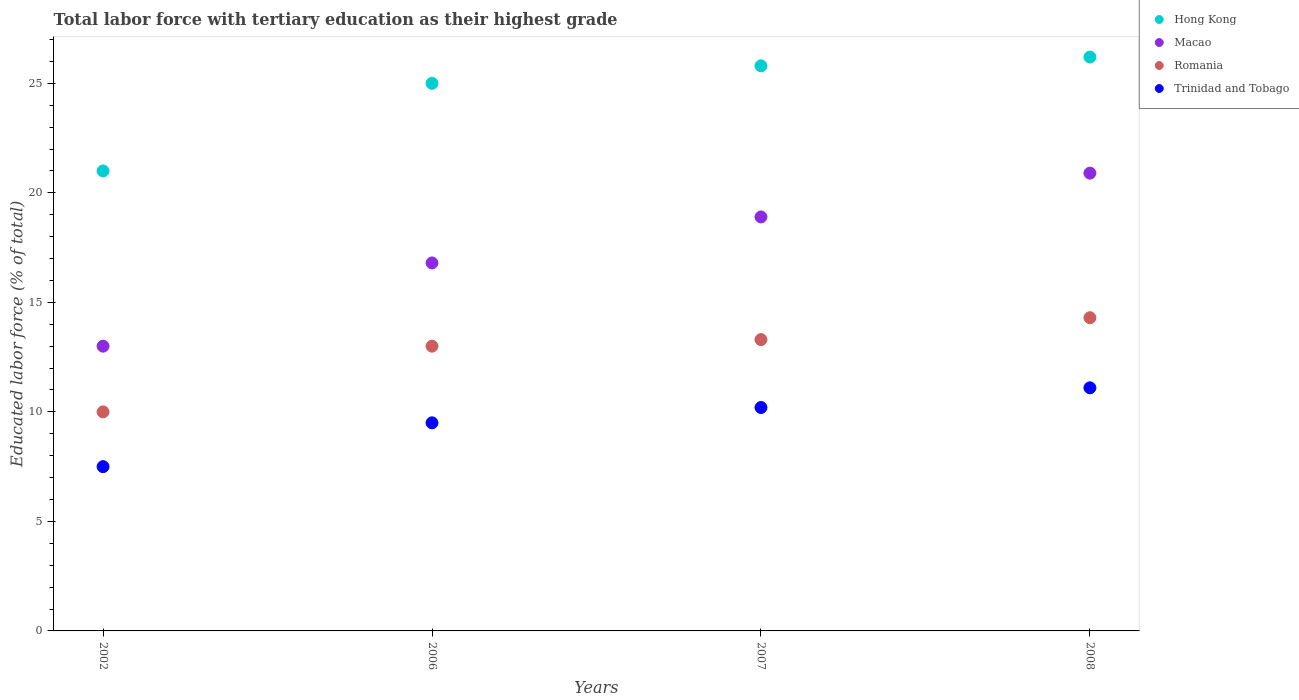How many different coloured dotlines are there?
Provide a short and direct response. 4. Is the number of dotlines equal to the number of legend labels?
Keep it short and to the point. Yes. What is the percentage of male labor force with tertiary education in Trinidad and Tobago in 2007?
Offer a terse response. 10.2. Across all years, what is the maximum percentage of male labor force with tertiary education in Trinidad and Tobago?
Your answer should be compact. 11.1. In which year was the percentage of male labor force with tertiary education in Romania maximum?
Give a very brief answer. 2008. What is the total percentage of male labor force with tertiary education in Macao in the graph?
Provide a short and direct response. 69.6. What is the difference between the percentage of male labor force with tertiary education in Macao in 2006 and that in 2007?
Ensure brevity in your answer.  -2.1. What is the difference between the percentage of male labor force with tertiary education in Hong Kong in 2006 and the percentage of male labor force with tertiary education in Trinidad and Tobago in 2008?
Your answer should be compact. 13.9. In the year 2008, what is the difference between the percentage of male labor force with tertiary education in Macao and percentage of male labor force with tertiary education in Trinidad and Tobago?
Ensure brevity in your answer.  9.8. What is the ratio of the percentage of male labor force with tertiary education in Macao in 2002 to that in 2008?
Ensure brevity in your answer.  0.62. What is the difference between the highest and the second highest percentage of male labor force with tertiary education in Trinidad and Tobago?
Keep it short and to the point. 0.9. What is the difference between the highest and the lowest percentage of male labor force with tertiary education in Macao?
Give a very brief answer. 7.9. In how many years, is the percentage of male labor force with tertiary education in Romania greater than the average percentage of male labor force with tertiary education in Romania taken over all years?
Your answer should be very brief. 3. Is the sum of the percentage of male labor force with tertiary education in Trinidad and Tobago in 2006 and 2007 greater than the maximum percentage of male labor force with tertiary education in Romania across all years?
Offer a very short reply. Yes. Is it the case that in every year, the sum of the percentage of male labor force with tertiary education in Trinidad and Tobago and percentage of male labor force with tertiary education in Romania  is greater than the sum of percentage of male labor force with tertiary education in Macao and percentage of male labor force with tertiary education in Hong Kong?
Offer a terse response. No. Is it the case that in every year, the sum of the percentage of male labor force with tertiary education in Hong Kong and percentage of male labor force with tertiary education in Romania  is greater than the percentage of male labor force with tertiary education in Macao?
Give a very brief answer. Yes. Is the percentage of male labor force with tertiary education in Romania strictly less than the percentage of male labor force with tertiary education in Hong Kong over the years?
Your answer should be compact. Yes. How many dotlines are there?
Make the answer very short. 4. How many years are there in the graph?
Give a very brief answer. 4. Does the graph contain any zero values?
Your answer should be compact. No. Does the graph contain grids?
Ensure brevity in your answer.  No. How are the legend labels stacked?
Keep it short and to the point. Vertical. What is the title of the graph?
Give a very brief answer. Total labor force with tertiary education as their highest grade. What is the label or title of the X-axis?
Keep it short and to the point. Years. What is the label or title of the Y-axis?
Ensure brevity in your answer.  Educated labor force (% of total). What is the Educated labor force (% of total) in Romania in 2002?
Ensure brevity in your answer.  10. What is the Educated labor force (% of total) of Macao in 2006?
Offer a very short reply. 16.8. What is the Educated labor force (% of total) in Romania in 2006?
Offer a terse response. 13. What is the Educated labor force (% of total) in Hong Kong in 2007?
Offer a terse response. 25.8. What is the Educated labor force (% of total) in Macao in 2007?
Keep it short and to the point. 18.9. What is the Educated labor force (% of total) of Romania in 2007?
Make the answer very short. 13.3. What is the Educated labor force (% of total) in Trinidad and Tobago in 2007?
Offer a very short reply. 10.2. What is the Educated labor force (% of total) in Hong Kong in 2008?
Provide a succinct answer. 26.2. What is the Educated labor force (% of total) in Macao in 2008?
Provide a short and direct response. 20.9. What is the Educated labor force (% of total) of Romania in 2008?
Provide a short and direct response. 14.3. What is the Educated labor force (% of total) of Trinidad and Tobago in 2008?
Make the answer very short. 11.1. Across all years, what is the maximum Educated labor force (% of total) of Hong Kong?
Your response must be concise. 26.2. Across all years, what is the maximum Educated labor force (% of total) in Macao?
Make the answer very short. 20.9. Across all years, what is the maximum Educated labor force (% of total) of Romania?
Provide a succinct answer. 14.3. Across all years, what is the maximum Educated labor force (% of total) of Trinidad and Tobago?
Provide a succinct answer. 11.1. What is the total Educated labor force (% of total) of Macao in the graph?
Give a very brief answer. 69.6. What is the total Educated labor force (% of total) of Romania in the graph?
Make the answer very short. 50.6. What is the total Educated labor force (% of total) in Trinidad and Tobago in the graph?
Your answer should be compact. 38.3. What is the difference between the Educated labor force (% of total) of Hong Kong in 2002 and that in 2006?
Provide a succinct answer. -4. What is the difference between the Educated labor force (% of total) in Macao in 2002 and that in 2006?
Give a very brief answer. -3.8. What is the difference between the Educated labor force (% of total) of Romania in 2002 and that in 2006?
Give a very brief answer. -3. What is the difference between the Educated labor force (% of total) in Trinidad and Tobago in 2002 and that in 2006?
Provide a short and direct response. -2. What is the difference between the Educated labor force (% of total) in Hong Kong in 2002 and that in 2007?
Offer a terse response. -4.8. What is the difference between the Educated labor force (% of total) in Romania in 2002 and that in 2007?
Your answer should be compact. -3.3. What is the difference between the Educated labor force (% of total) in Hong Kong in 2002 and that in 2008?
Make the answer very short. -5.2. What is the difference between the Educated labor force (% of total) in Macao in 2002 and that in 2008?
Give a very brief answer. -7.9. What is the difference between the Educated labor force (% of total) of Trinidad and Tobago in 2002 and that in 2008?
Provide a short and direct response. -3.6. What is the difference between the Educated labor force (% of total) of Romania in 2006 and that in 2007?
Provide a short and direct response. -0.3. What is the difference between the Educated labor force (% of total) in Macao in 2006 and that in 2008?
Provide a short and direct response. -4.1. What is the difference between the Educated labor force (% of total) of Romania in 2006 and that in 2008?
Offer a very short reply. -1.3. What is the difference between the Educated labor force (% of total) in Trinidad and Tobago in 2006 and that in 2008?
Offer a very short reply. -1.6. What is the difference between the Educated labor force (% of total) of Hong Kong in 2002 and the Educated labor force (% of total) of Macao in 2006?
Your response must be concise. 4.2. What is the difference between the Educated labor force (% of total) of Hong Kong in 2002 and the Educated labor force (% of total) of Trinidad and Tobago in 2006?
Give a very brief answer. 11.5. What is the difference between the Educated labor force (% of total) of Macao in 2002 and the Educated labor force (% of total) of Romania in 2006?
Ensure brevity in your answer.  0. What is the difference between the Educated labor force (% of total) of Romania in 2002 and the Educated labor force (% of total) of Trinidad and Tobago in 2006?
Offer a very short reply. 0.5. What is the difference between the Educated labor force (% of total) in Hong Kong in 2002 and the Educated labor force (% of total) in Macao in 2007?
Offer a terse response. 2.1. What is the difference between the Educated labor force (% of total) of Hong Kong in 2002 and the Educated labor force (% of total) of Trinidad and Tobago in 2007?
Your answer should be very brief. 10.8. What is the difference between the Educated labor force (% of total) in Hong Kong in 2002 and the Educated labor force (% of total) in Macao in 2008?
Your response must be concise. 0.1. What is the difference between the Educated labor force (% of total) in Macao in 2002 and the Educated labor force (% of total) in Trinidad and Tobago in 2008?
Offer a very short reply. 1.9. What is the difference between the Educated labor force (% of total) of Hong Kong in 2006 and the Educated labor force (% of total) of Macao in 2007?
Your answer should be compact. 6.1. What is the difference between the Educated labor force (% of total) in Hong Kong in 2006 and the Educated labor force (% of total) in Romania in 2007?
Give a very brief answer. 11.7. What is the difference between the Educated labor force (% of total) in Macao in 2006 and the Educated labor force (% of total) in Trinidad and Tobago in 2007?
Provide a short and direct response. 6.6. What is the difference between the Educated labor force (% of total) in Hong Kong in 2006 and the Educated labor force (% of total) in Romania in 2008?
Your answer should be very brief. 10.7. What is the difference between the Educated labor force (% of total) of Hong Kong in 2006 and the Educated labor force (% of total) of Trinidad and Tobago in 2008?
Offer a terse response. 13.9. What is the difference between the Educated labor force (% of total) of Macao in 2006 and the Educated labor force (% of total) of Trinidad and Tobago in 2008?
Your response must be concise. 5.7. What is the difference between the Educated labor force (% of total) in Romania in 2006 and the Educated labor force (% of total) in Trinidad and Tobago in 2008?
Your answer should be compact. 1.9. What is the difference between the Educated labor force (% of total) in Hong Kong in 2007 and the Educated labor force (% of total) in Trinidad and Tobago in 2008?
Your response must be concise. 14.7. What is the difference between the Educated labor force (% of total) of Romania in 2007 and the Educated labor force (% of total) of Trinidad and Tobago in 2008?
Your response must be concise. 2.2. What is the average Educated labor force (% of total) of Macao per year?
Your answer should be compact. 17.4. What is the average Educated labor force (% of total) of Romania per year?
Provide a short and direct response. 12.65. What is the average Educated labor force (% of total) in Trinidad and Tobago per year?
Your answer should be compact. 9.57. In the year 2002, what is the difference between the Educated labor force (% of total) of Hong Kong and Educated labor force (% of total) of Romania?
Offer a terse response. 11. In the year 2006, what is the difference between the Educated labor force (% of total) in Hong Kong and Educated labor force (% of total) in Macao?
Provide a short and direct response. 8.2. In the year 2006, what is the difference between the Educated labor force (% of total) of Macao and Educated labor force (% of total) of Trinidad and Tobago?
Give a very brief answer. 7.3. In the year 2007, what is the difference between the Educated labor force (% of total) of Hong Kong and Educated labor force (% of total) of Macao?
Make the answer very short. 6.9. In the year 2007, what is the difference between the Educated labor force (% of total) in Macao and Educated labor force (% of total) in Romania?
Your response must be concise. 5.6. In the year 2007, what is the difference between the Educated labor force (% of total) in Romania and Educated labor force (% of total) in Trinidad and Tobago?
Your response must be concise. 3.1. In the year 2008, what is the difference between the Educated labor force (% of total) in Hong Kong and Educated labor force (% of total) in Macao?
Your answer should be compact. 5.3. In the year 2008, what is the difference between the Educated labor force (% of total) of Romania and Educated labor force (% of total) of Trinidad and Tobago?
Offer a very short reply. 3.2. What is the ratio of the Educated labor force (% of total) of Hong Kong in 2002 to that in 2006?
Your answer should be very brief. 0.84. What is the ratio of the Educated labor force (% of total) of Macao in 2002 to that in 2006?
Ensure brevity in your answer.  0.77. What is the ratio of the Educated labor force (% of total) of Romania in 2002 to that in 2006?
Your answer should be compact. 0.77. What is the ratio of the Educated labor force (% of total) in Trinidad and Tobago in 2002 to that in 2006?
Offer a very short reply. 0.79. What is the ratio of the Educated labor force (% of total) of Hong Kong in 2002 to that in 2007?
Provide a succinct answer. 0.81. What is the ratio of the Educated labor force (% of total) in Macao in 2002 to that in 2007?
Your answer should be compact. 0.69. What is the ratio of the Educated labor force (% of total) of Romania in 2002 to that in 2007?
Offer a terse response. 0.75. What is the ratio of the Educated labor force (% of total) in Trinidad and Tobago in 2002 to that in 2007?
Give a very brief answer. 0.74. What is the ratio of the Educated labor force (% of total) in Hong Kong in 2002 to that in 2008?
Offer a terse response. 0.8. What is the ratio of the Educated labor force (% of total) of Macao in 2002 to that in 2008?
Ensure brevity in your answer.  0.62. What is the ratio of the Educated labor force (% of total) of Romania in 2002 to that in 2008?
Your response must be concise. 0.7. What is the ratio of the Educated labor force (% of total) in Trinidad and Tobago in 2002 to that in 2008?
Your answer should be very brief. 0.68. What is the ratio of the Educated labor force (% of total) of Hong Kong in 2006 to that in 2007?
Your response must be concise. 0.97. What is the ratio of the Educated labor force (% of total) of Macao in 2006 to that in 2007?
Ensure brevity in your answer.  0.89. What is the ratio of the Educated labor force (% of total) in Romania in 2006 to that in 2007?
Keep it short and to the point. 0.98. What is the ratio of the Educated labor force (% of total) of Trinidad and Tobago in 2006 to that in 2007?
Offer a terse response. 0.93. What is the ratio of the Educated labor force (% of total) in Hong Kong in 2006 to that in 2008?
Provide a short and direct response. 0.95. What is the ratio of the Educated labor force (% of total) of Macao in 2006 to that in 2008?
Your answer should be very brief. 0.8. What is the ratio of the Educated labor force (% of total) of Trinidad and Tobago in 2006 to that in 2008?
Keep it short and to the point. 0.86. What is the ratio of the Educated labor force (% of total) in Hong Kong in 2007 to that in 2008?
Your answer should be very brief. 0.98. What is the ratio of the Educated labor force (% of total) of Macao in 2007 to that in 2008?
Your response must be concise. 0.9. What is the ratio of the Educated labor force (% of total) in Romania in 2007 to that in 2008?
Give a very brief answer. 0.93. What is the ratio of the Educated labor force (% of total) of Trinidad and Tobago in 2007 to that in 2008?
Offer a terse response. 0.92. What is the difference between the highest and the second highest Educated labor force (% of total) of Hong Kong?
Ensure brevity in your answer.  0.4. What is the difference between the highest and the second highest Educated labor force (% of total) in Macao?
Offer a terse response. 2. What is the difference between the highest and the lowest Educated labor force (% of total) of Macao?
Provide a succinct answer. 7.9. What is the difference between the highest and the lowest Educated labor force (% of total) of Romania?
Provide a succinct answer. 4.3. 